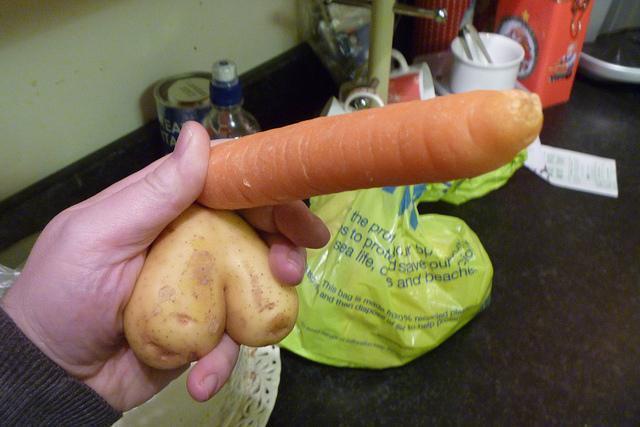How many carrots are in the picture?
Give a very brief answer. 1. 